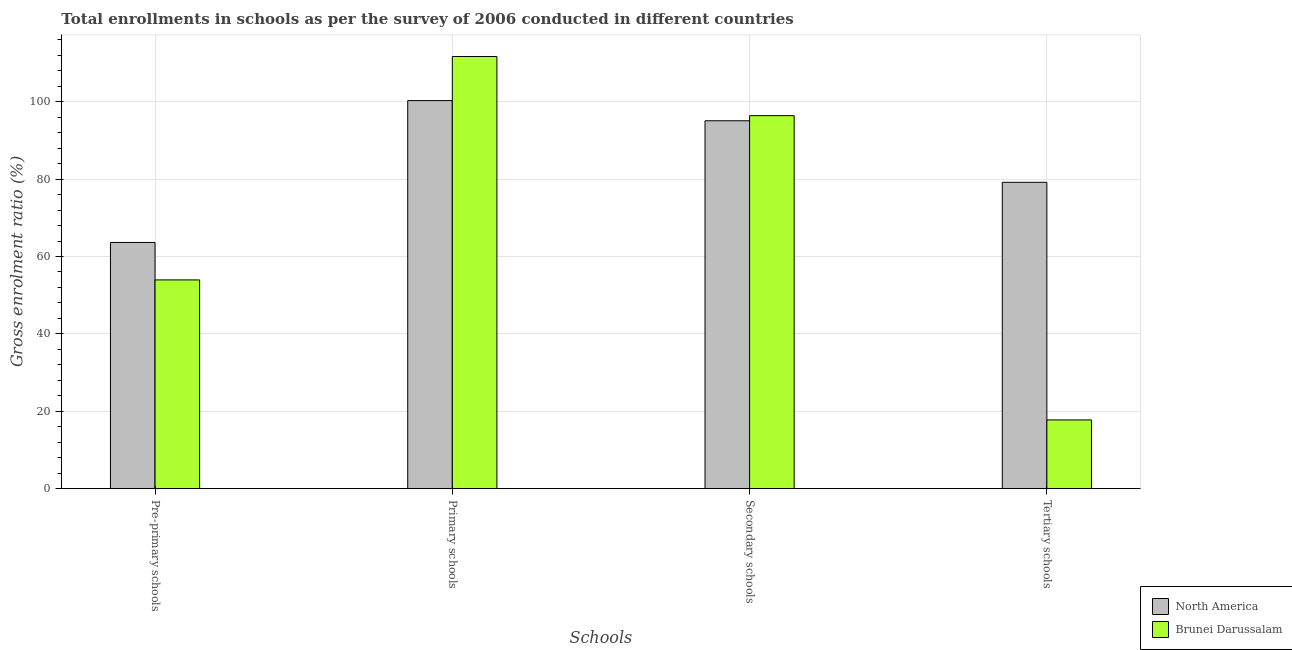How many different coloured bars are there?
Provide a succinct answer. 2. How many groups of bars are there?
Your answer should be very brief. 4. Are the number of bars on each tick of the X-axis equal?
Your answer should be very brief. Yes. How many bars are there on the 4th tick from the right?
Your response must be concise. 2. What is the label of the 1st group of bars from the left?
Offer a terse response. Pre-primary schools. What is the gross enrolment ratio in tertiary schools in North America?
Keep it short and to the point. 79.17. Across all countries, what is the maximum gross enrolment ratio in pre-primary schools?
Your answer should be compact. 63.62. Across all countries, what is the minimum gross enrolment ratio in primary schools?
Keep it short and to the point. 100.29. In which country was the gross enrolment ratio in secondary schools maximum?
Make the answer very short. Brunei Darussalam. In which country was the gross enrolment ratio in tertiary schools minimum?
Your answer should be compact. Brunei Darussalam. What is the total gross enrolment ratio in primary schools in the graph?
Provide a short and direct response. 211.97. What is the difference between the gross enrolment ratio in secondary schools in Brunei Darussalam and that in North America?
Offer a very short reply. 1.32. What is the difference between the gross enrolment ratio in pre-primary schools in Brunei Darussalam and the gross enrolment ratio in tertiary schools in North America?
Keep it short and to the point. -25.23. What is the average gross enrolment ratio in pre-primary schools per country?
Offer a terse response. 58.78. What is the difference between the gross enrolment ratio in pre-primary schools and gross enrolment ratio in primary schools in North America?
Your response must be concise. -36.66. What is the ratio of the gross enrolment ratio in primary schools in Brunei Darussalam to that in North America?
Make the answer very short. 1.11. Is the difference between the gross enrolment ratio in primary schools in Brunei Darussalam and North America greater than the difference between the gross enrolment ratio in pre-primary schools in Brunei Darussalam and North America?
Ensure brevity in your answer.  Yes. What is the difference between the highest and the second highest gross enrolment ratio in tertiary schools?
Your response must be concise. 61.41. What is the difference between the highest and the lowest gross enrolment ratio in pre-primary schools?
Your answer should be compact. 9.68. Is the sum of the gross enrolment ratio in secondary schools in North America and Brunei Darussalam greater than the maximum gross enrolment ratio in pre-primary schools across all countries?
Keep it short and to the point. Yes. What does the 2nd bar from the left in Secondary schools represents?
Make the answer very short. Brunei Darussalam. What does the 1st bar from the right in Primary schools represents?
Make the answer very short. Brunei Darussalam. Is it the case that in every country, the sum of the gross enrolment ratio in pre-primary schools and gross enrolment ratio in primary schools is greater than the gross enrolment ratio in secondary schools?
Ensure brevity in your answer.  Yes. How many countries are there in the graph?
Your response must be concise. 2. Does the graph contain grids?
Keep it short and to the point. Yes. Where does the legend appear in the graph?
Keep it short and to the point. Bottom right. How many legend labels are there?
Ensure brevity in your answer.  2. What is the title of the graph?
Provide a short and direct response. Total enrollments in schools as per the survey of 2006 conducted in different countries. Does "Finland" appear as one of the legend labels in the graph?
Offer a very short reply. No. What is the label or title of the X-axis?
Ensure brevity in your answer.  Schools. What is the label or title of the Y-axis?
Your answer should be very brief. Gross enrolment ratio (%). What is the Gross enrolment ratio (%) in North America in Pre-primary schools?
Your response must be concise. 63.62. What is the Gross enrolment ratio (%) in Brunei Darussalam in Pre-primary schools?
Provide a succinct answer. 53.94. What is the Gross enrolment ratio (%) in North America in Primary schools?
Offer a terse response. 100.29. What is the Gross enrolment ratio (%) of Brunei Darussalam in Primary schools?
Provide a short and direct response. 111.68. What is the Gross enrolment ratio (%) of North America in Secondary schools?
Ensure brevity in your answer.  95.07. What is the Gross enrolment ratio (%) in Brunei Darussalam in Secondary schools?
Make the answer very short. 96.39. What is the Gross enrolment ratio (%) in North America in Tertiary schools?
Provide a succinct answer. 79.17. What is the Gross enrolment ratio (%) in Brunei Darussalam in Tertiary schools?
Offer a terse response. 17.77. Across all Schools, what is the maximum Gross enrolment ratio (%) in North America?
Offer a terse response. 100.29. Across all Schools, what is the maximum Gross enrolment ratio (%) in Brunei Darussalam?
Your response must be concise. 111.68. Across all Schools, what is the minimum Gross enrolment ratio (%) in North America?
Provide a short and direct response. 63.62. Across all Schools, what is the minimum Gross enrolment ratio (%) in Brunei Darussalam?
Your answer should be compact. 17.77. What is the total Gross enrolment ratio (%) in North America in the graph?
Keep it short and to the point. 338.15. What is the total Gross enrolment ratio (%) of Brunei Darussalam in the graph?
Offer a terse response. 279.79. What is the difference between the Gross enrolment ratio (%) in North America in Pre-primary schools and that in Primary schools?
Give a very brief answer. -36.66. What is the difference between the Gross enrolment ratio (%) in Brunei Darussalam in Pre-primary schools and that in Primary schools?
Offer a terse response. -57.74. What is the difference between the Gross enrolment ratio (%) of North America in Pre-primary schools and that in Secondary schools?
Offer a terse response. -31.45. What is the difference between the Gross enrolment ratio (%) of Brunei Darussalam in Pre-primary schools and that in Secondary schools?
Your answer should be very brief. -42.45. What is the difference between the Gross enrolment ratio (%) of North America in Pre-primary schools and that in Tertiary schools?
Your response must be concise. -15.55. What is the difference between the Gross enrolment ratio (%) in Brunei Darussalam in Pre-primary schools and that in Tertiary schools?
Give a very brief answer. 36.18. What is the difference between the Gross enrolment ratio (%) in North America in Primary schools and that in Secondary schools?
Your response must be concise. 5.22. What is the difference between the Gross enrolment ratio (%) in Brunei Darussalam in Primary schools and that in Secondary schools?
Provide a short and direct response. 15.29. What is the difference between the Gross enrolment ratio (%) of North America in Primary schools and that in Tertiary schools?
Provide a succinct answer. 21.11. What is the difference between the Gross enrolment ratio (%) in Brunei Darussalam in Primary schools and that in Tertiary schools?
Make the answer very short. 93.92. What is the difference between the Gross enrolment ratio (%) of North America in Secondary schools and that in Tertiary schools?
Provide a succinct answer. 15.89. What is the difference between the Gross enrolment ratio (%) in Brunei Darussalam in Secondary schools and that in Tertiary schools?
Ensure brevity in your answer.  78.63. What is the difference between the Gross enrolment ratio (%) of North America in Pre-primary schools and the Gross enrolment ratio (%) of Brunei Darussalam in Primary schools?
Your answer should be compact. -48.06. What is the difference between the Gross enrolment ratio (%) of North America in Pre-primary schools and the Gross enrolment ratio (%) of Brunei Darussalam in Secondary schools?
Your response must be concise. -32.77. What is the difference between the Gross enrolment ratio (%) in North America in Pre-primary schools and the Gross enrolment ratio (%) in Brunei Darussalam in Tertiary schools?
Your answer should be compact. 45.86. What is the difference between the Gross enrolment ratio (%) of North America in Primary schools and the Gross enrolment ratio (%) of Brunei Darussalam in Secondary schools?
Give a very brief answer. 3.89. What is the difference between the Gross enrolment ratio (%) in North America in Primary schools and the Gross enrolment ratio (%) in Brunei Darussalam in Tertiary schools?
Ensure brevity in your answer.  82.52. What is the difference between the Gross enrolment ratio (%) of North America in Secondary schools and the Gross enrolment ratio (%) of Brunei Darussalam in Tertiary schools?
Offer a terse response. 77.3. What is the average Gross enrolment ratio (%) of North America per Schools?
Your answer should be compact. 84.54. What is the average Gross enrolment ratio (%) of Brunei Darussalam per Schools?
Keep it short and to the point. 69.95. What is the difference between the Gross enrolment ratio (%) in North America and Gross enrolment ratio (%) in Brunei Darussalam in Pre-primary schools?
Ensure brevity in your answer.  9.68. What is the difference between the Gross enrolment ratio (%) in North America and Gross enrolment ratio (%) in Brunei Darussalam in Primary schools?
Your answer should be very brief. -11.4. What is the difference between the Gross enrolment ratio (%) of North America and Gross enrolment ratio (%) of Brunei Darussalam in Secondary schools?
Give a very brief answer. -1.32. What is the difference between the Gross enrolment ratio (%) in North America and Gross enrolment ratio (%) in Brunei Darussalam in Tertiary schools?
Ensure brevity in your answer.  61.41. What is the ratio of the Gross enrolment ratio (%) of North America in Pre-primary schools to that in Primary schools?
Make the answer very short. 0.63. What is the ratio of the Gross enrolment ratio (%) of Brunei Darussalam in Pre-primary schools to that in Primary schools?
Your response must be concise. 0.48. What is the ratio of the Gross enrolment ratio (%) in North America in Pre-primary schools to that in Secondary schools?
Make the answer very short. 0.67. What is the ratio of the Gross enrolment ratio (%) in Brunei Darussalam in Pre-primary schools to that in Secondary schools?
Offer a very short reply. 0.56. What is the ratio of the Gross enrolment ratio (%) of North America in Pre-primary schools to that in Tertiary schools?
Your answer should be compact. 0.8. What is the ratio of the Gross enrolment ratio (%) in Brunei Darussalam in Pre-primary schools to that in Tertiary schools?
Your answer should be very brief. 3.04. What is the ratio of the Gross enrolment ratio (%) in North America in Primary schools to that in Secondary schools?
Provide a succinct answer. 1.05. What is the ratio of the Gross enrolment ratio (%) of Brunei Darussalam in Primary schools to that in Secondary schools?
Provide a succinct answer. 1.16. What is the ratio of the Gross enrolment ratio (%) in North America in Primary schools to that in Tertiary schools?
Offer a terse response. 1.27. What is the ratio of the Gross enrolment ratio (%) of Brunei Darussalam in Primary schools to that in Tertiary schools?
Keep it short and to the point. 6.29. What is the ratio of the Gross enrolment ratio (%) of North America in Secondary schools to that in Tertiary schools?
Your answer should be very brief. 1.2. What is the ratio of the Gross enrolment ratio (%) in Brunei Darussalam in Secondary schools to that in Tertiary schools?
Offer a terse response. 5.43. What is the difference between the highest and the second highest Gross enrolment ratio (%) of North America?
Offer a terse response. 5.22. What is the difference between the highest and the second highest Gross enrolment ratio (%) in Brunei Darussalam?
Ensure brevity in your answer.  15.29. What is the difference between the highest and the lowest Gross enrolment ratio (%) of North America?
Your answer should be very brief. 36.66. What is the difference between the highest and the lowest Gross enrolment ratio (%) in Brunei Darussalam?
Give a very brief answer. 93.92. 